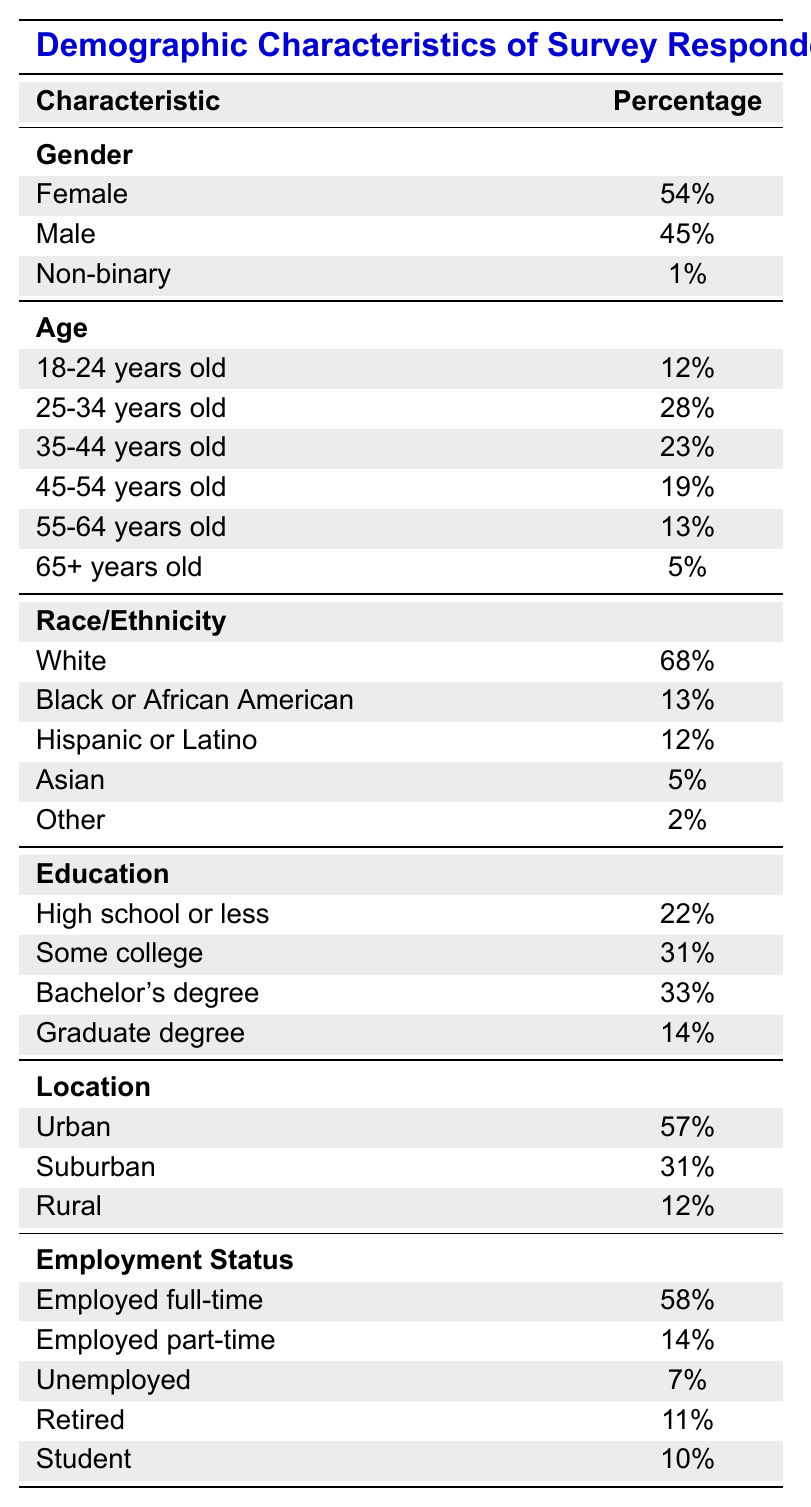What percentage of respondents identified as Female? The table indicates that 54% of the respondents identified as Female.
Answer: 54% What is the percentage of respondents aged 65 and older? The table shows that 5% of the respondents are aged 65 and older.
Answer: 5% What is the proportion of respondents with a Bachelor's degree or higher? To find this, we add the percentages of those with a Bachelor's degree (33%) and Graduate degree (14%): 33% + 14% = 47%.
Answer: 47% What percentage of respondents are either Black or Hispanic? The table lists 13% for Black or African American and 12% for Hispanic or Latino. Adding these gives: 13% + 12% = 25%.
Answer: 25% Is the percentage of Urban respondents greater than that of Rural respondents? The table shows that Urban respondents constitute 57%, while Rural respondents make up 12%, so 57% > 12% is true.
Answer: Yes How many respondents have some form of college education (Some college, Bachelor's degree, Graduate degree)? To determine this, sum the percentages for Some college (31%), Bachelor's degree (33%), and Graduate degree (14%): 31% + 33% + 14% = 78%.
Answer: 78% Which age group has the highest percentage of respondents? The age group with the highest percentage is 25-34 years old at 28%, which is greater than all other age categories listed.
Answer: 25-34 years old What is the difference between the percentage of respondents who are employed full-time and those who are unemployed? The full-time employment percentage is 58%, and unemployment is 7%. The difference is: 58% - 7% = 51%.
Answer: 51% What percentage of respondents identify as Non-binary? The table specifies that 1% of respondents identify as Non-binary.
Answer: 1% Are there more respondents from Suburban areas than those who are Retired? Suburban respondents constitute 31%, while Retired respondents account for 11%. Since 31% > 11%, it is true.
Answer: Yes 